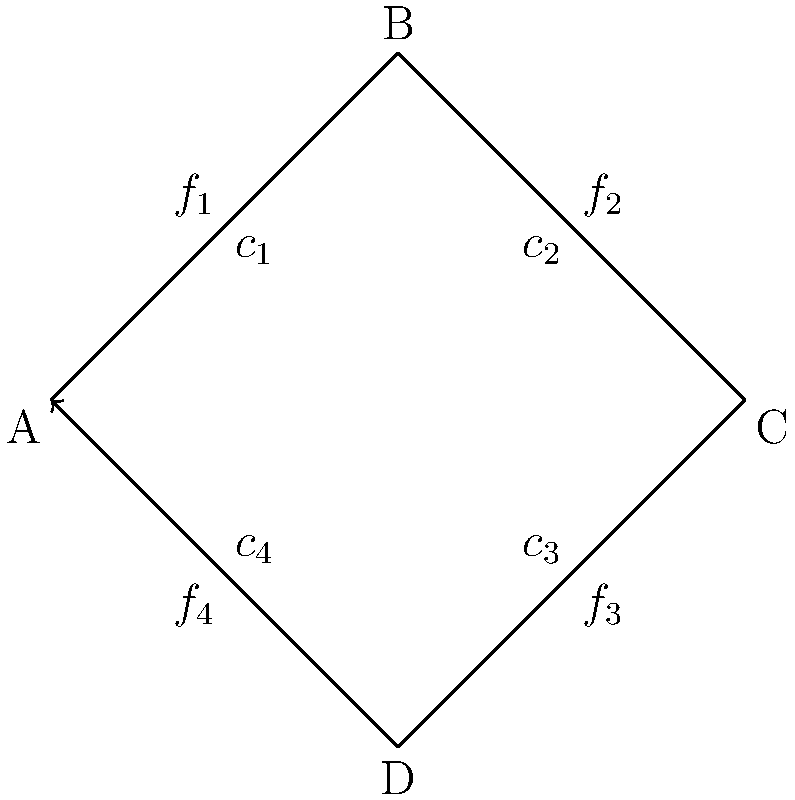In the given network flow representation of a pipeline system, nodes represent junctions and edges represent pipes. The flow $f_i$ in each pipe is subject to capacity constraints $c_i$. Assuming steady-state flow and conservation of mass at each junction, which of the following equations correctly represents the conservation of flow at node B? To solve this problem, we need to understand the principles of network flow and conservation of mass in fluid dynamics. Let's break it down step-by-step:

1. In a steady-state flow network, the conservation of mass principle states that the total flow into a node must equal the total flow out of the node.

2. For node B, we need to identify the incoming and outgoing flows:
   - Incoming flow: $f_1$ (from A to B)
   - Outgoing flow: $f_2$ (from B to C)

3. According to the conservation of mass principle, these flows must be equal:

   $f_1 = f_2$

4. We can also express this equality in terms of the other flows in the system. Since the network forms a closed loop, we know that:

   $f_1 + f_2 + f_3 + f_4 = 0$

   This is because the total flow in a closed loop must sum to zero.

5. From this, we can derive:

   $f_2 = -(f_1 + f_3 + f_4)$

6. Substituting this into our original equality:

   $f_1 = -(f_1 + f_3 + f_4)$

7. Simplifying:

   $2f_1 + f_3 + f_4 = 0$

   or

   $f_1 = -\frac{1}{2}(f_3 + f_4)$

This final equation correctly represents the conservation of flow at node B in terms of the other flows in the system.
Answer: $f_1 = -\frac{1}{2}(f_3 + f_4)$ 